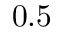<formula> <loc_0><loc_0><loc_500><loc_500>0 . 5</formula> 